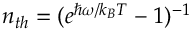Convert formula to latex. <formula><loc_0><loc_0><loc_500><loc_500>n _ { t h } = ( e ^ { \hbar { \omega } / k _ { B } T } - 1 ) ^ { - 1 }</formula> 